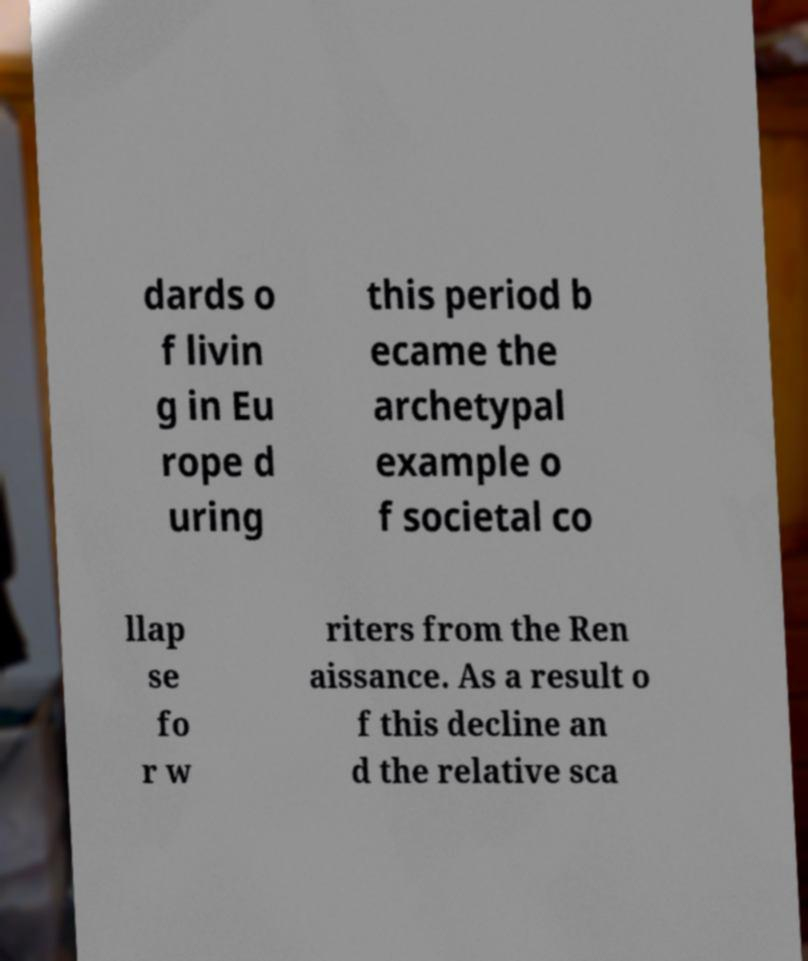There's text embedded in this image that I need extracted. Can you transcribe it verbatim? dards o f livin g in Eu rope d uring this period b ecame the archetypal example o f societal co llap se fo r w riters from the Ren aissance. As a result o f this decline an d the relative sca 